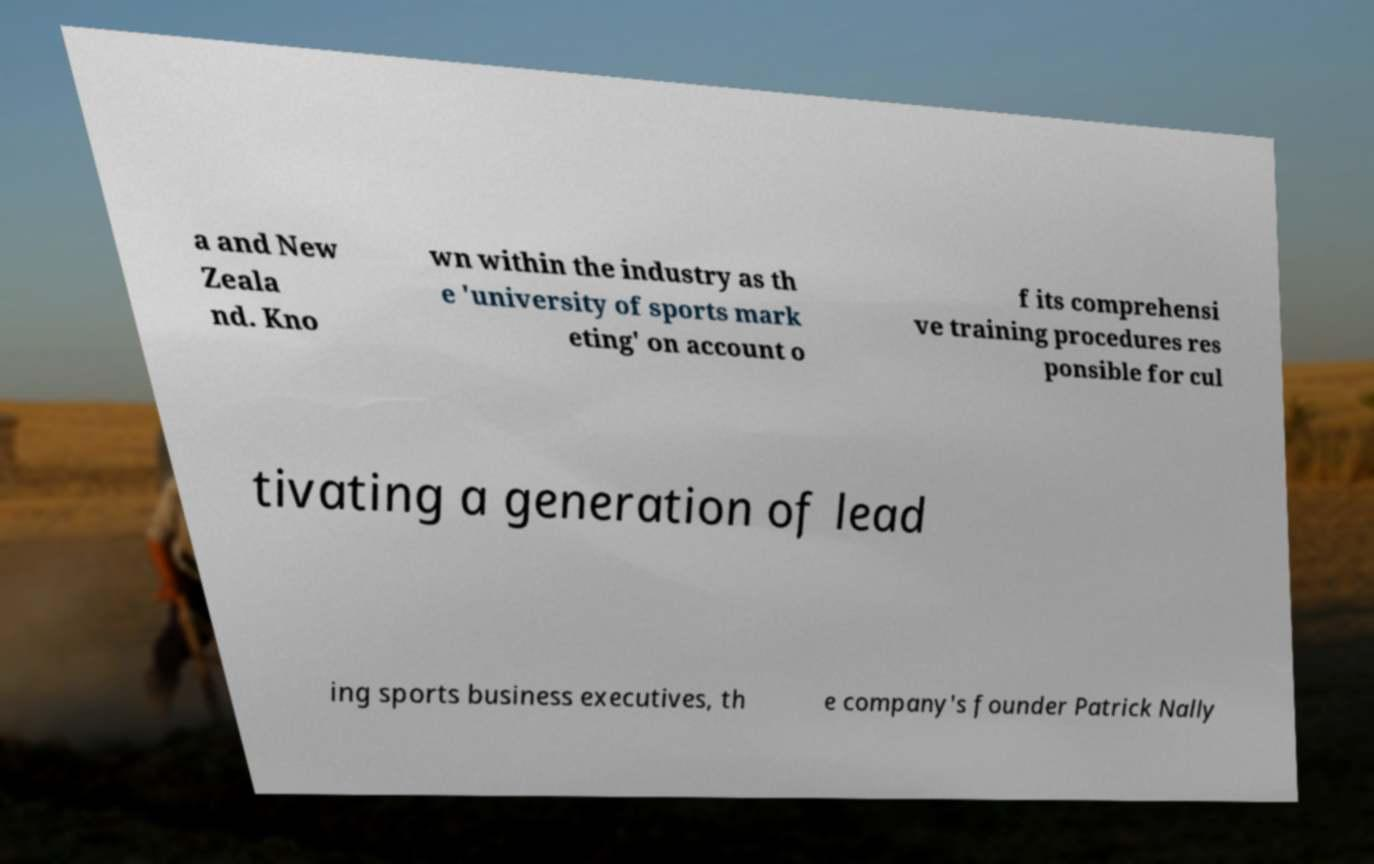Can you read and provide the text displayed in the image?This photo seems to have some interesting text. Can you extract and type it out for me? a and New Zeala nd. Kno wn within the industry as th e 'university of sports mark eting' on account o f its comprehensi ve training procedures res ponsible for cul tivating a generation of lead ing sports business executives, th e company's founder Patrick Nally 